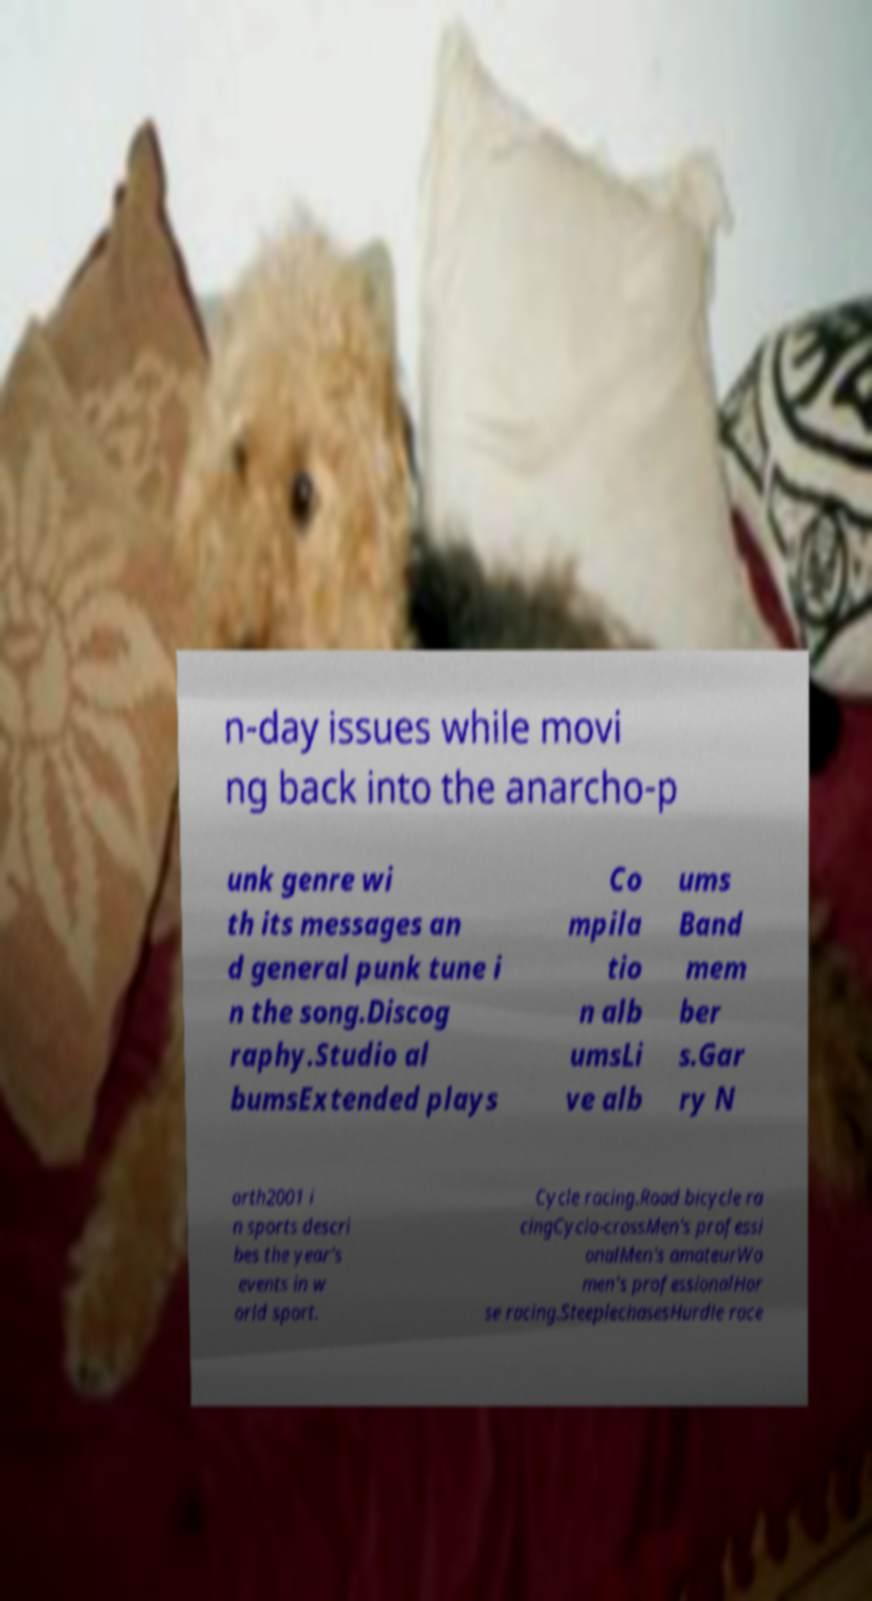Could you extract and type out the text from this image? n-day issues while movi ng back into the anarcho-p unk genre wi th its messages an d general punk tune i n the song.Discog raphy.Studio al bumsExtended plays Co mpila tio n alb umsLi ve alb ums Band mem ber s.Gar ry N orth2001 i n sports descri bes the year's events in w orld sport. Cycle racing.Road bicycle ra cingCyclo-crossMen's professi onalMen's amateurWo men's professionalHor se racing.SteeplechasesHurdle race 